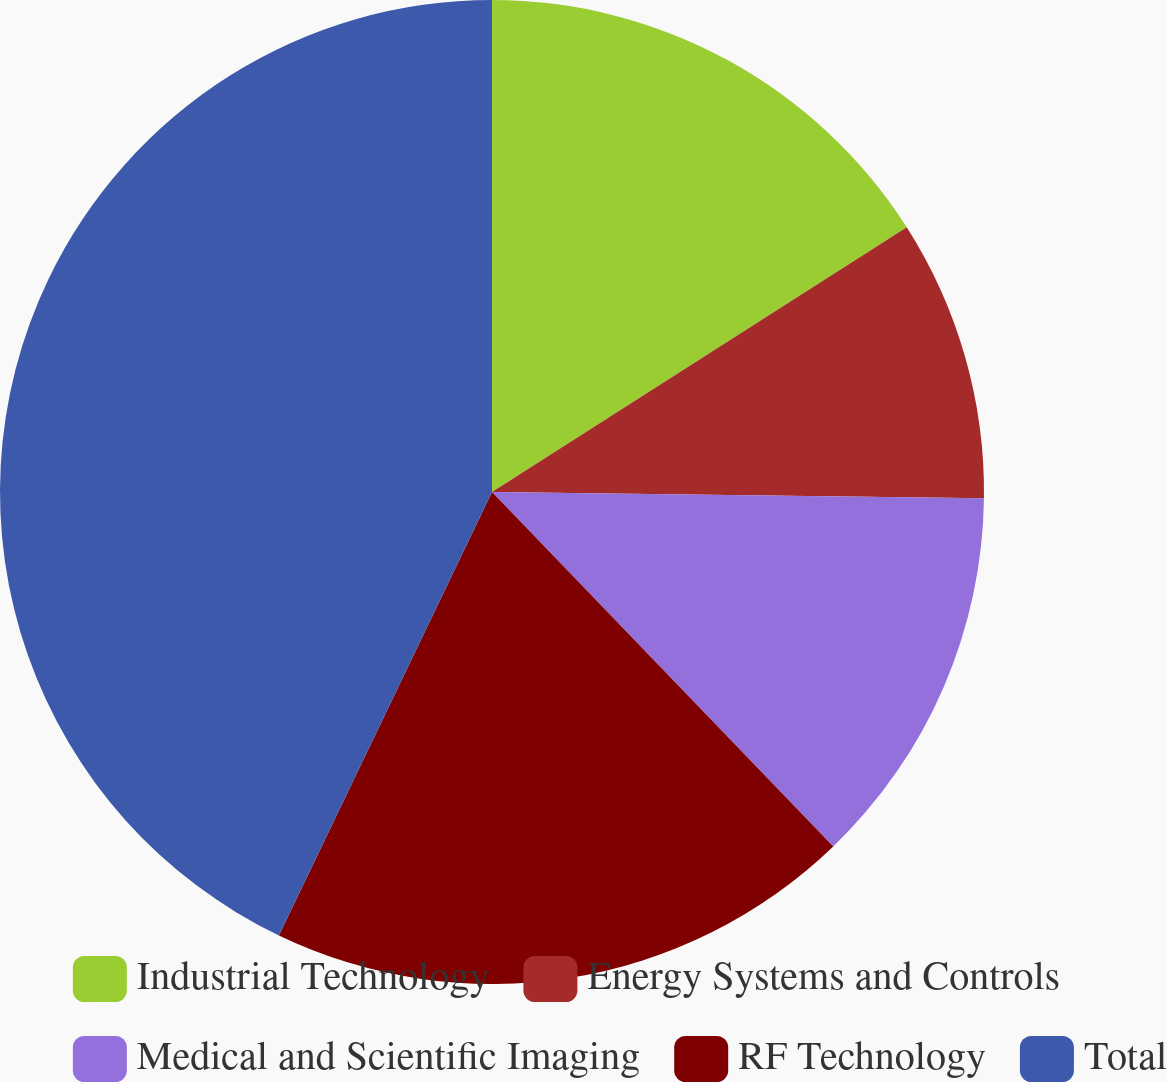Convert chart to OTSL. <chart><loc_0><loc_0><loc_500><loc_500><pie_chart><fcel>Industrial Technology<fcel>Energy Systems and Controls<fcel>Medical and Scientific Imaging<fcel>RF Technology<fcel>Total<nl><fcel>15.96%<fcel>9.24%<fcel>12.6%<fcel>19.33%<fcel>42.87%<nl></chart> 